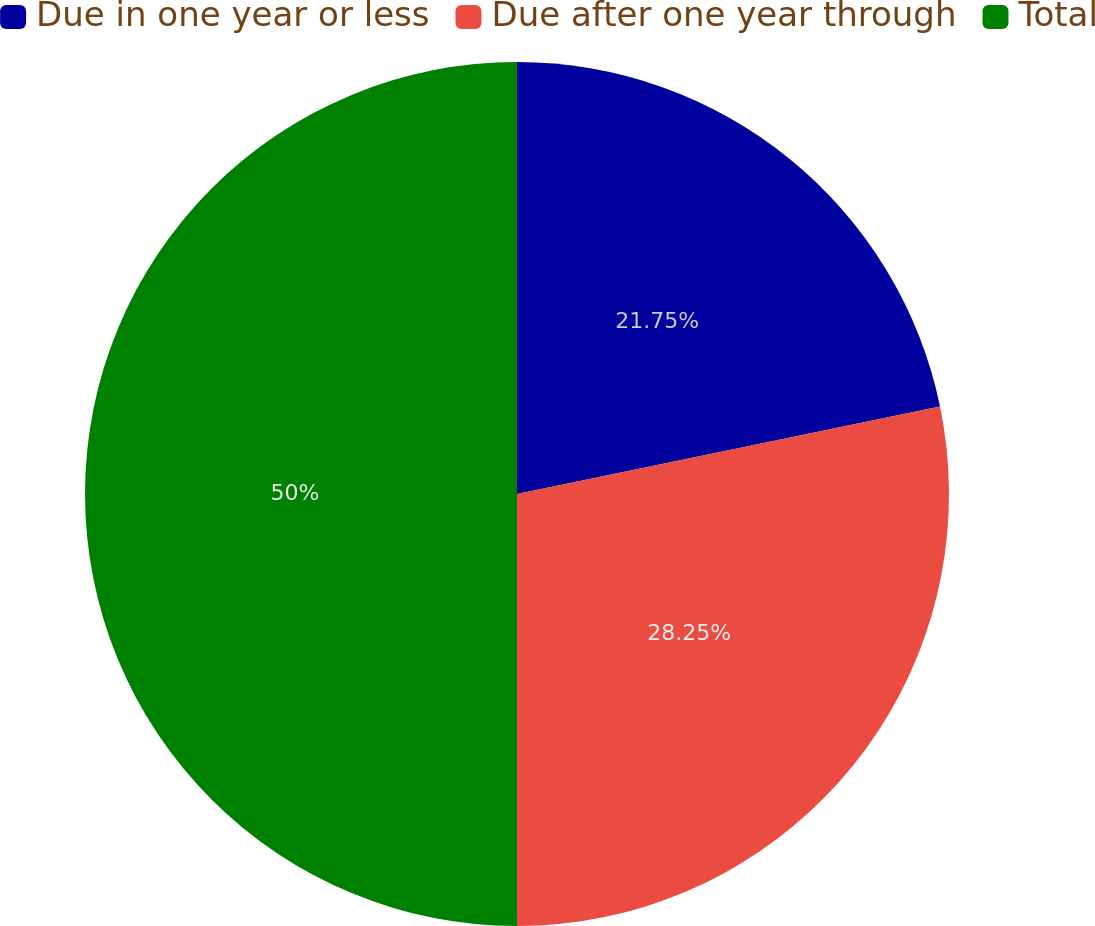<chart> <loc_0><loc_0><loc_500><loc_500><pie_chart><fcel>Due in one year or less<fcel>Due after one year through<fcel>Total<nl><fcel>21.75%<fcel>28.25%<fcel>50.0%<nl></chart> 